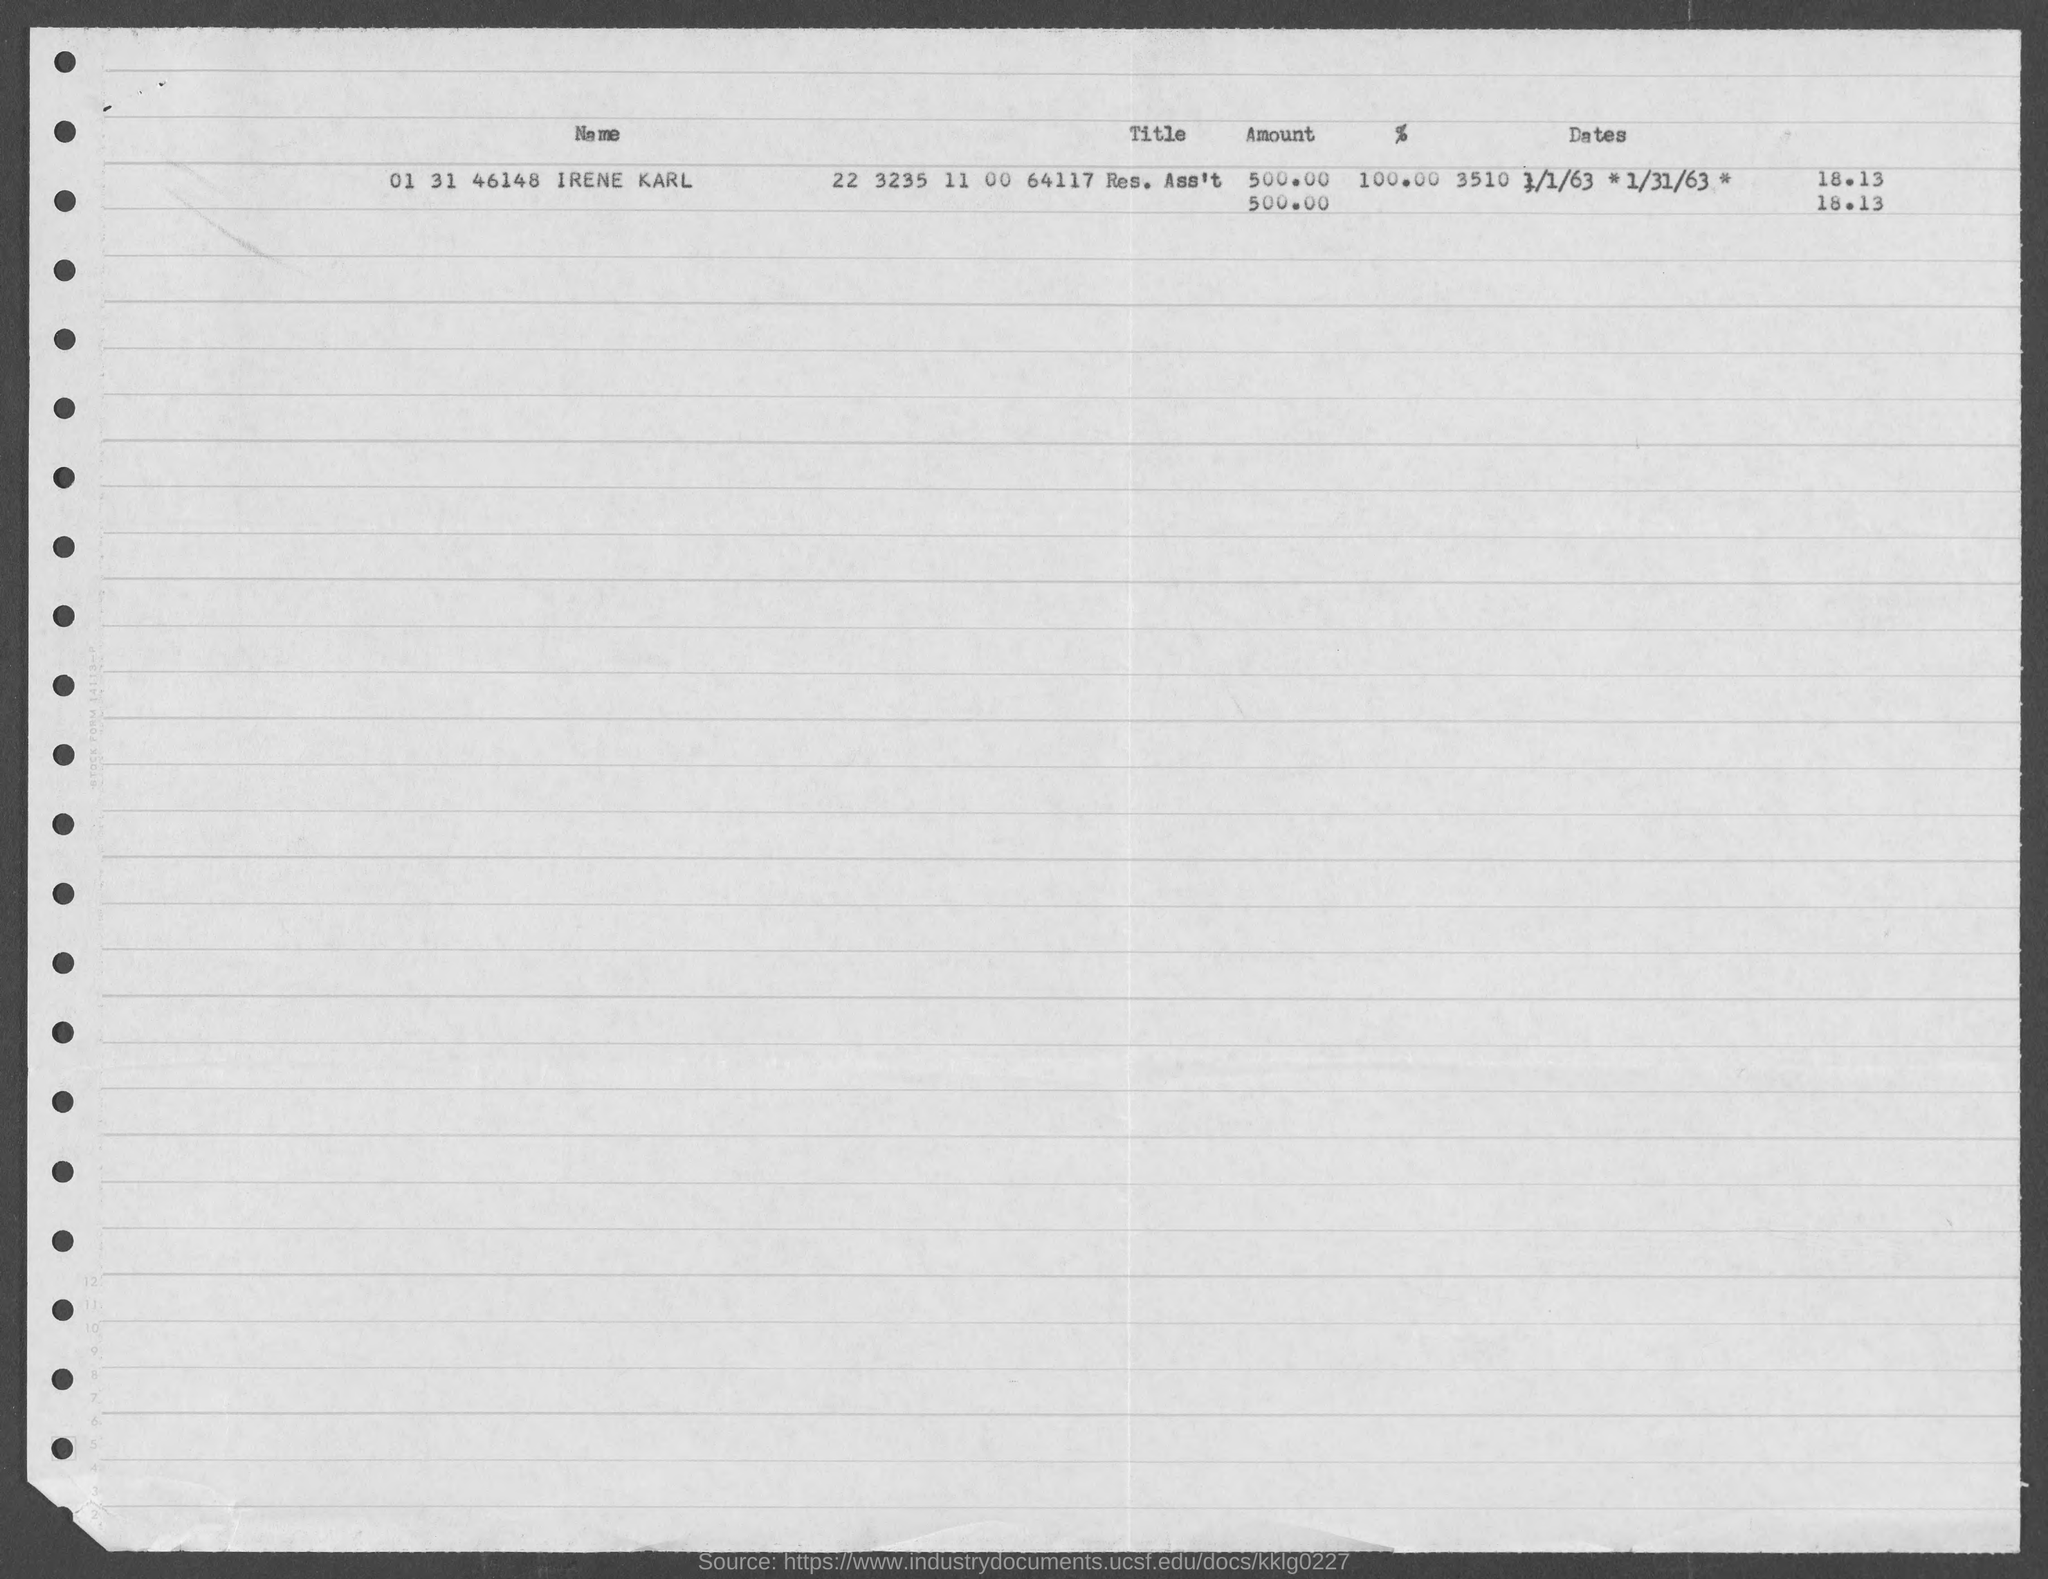Give some essential details in this illustration. The name given is IRENE KARL. 